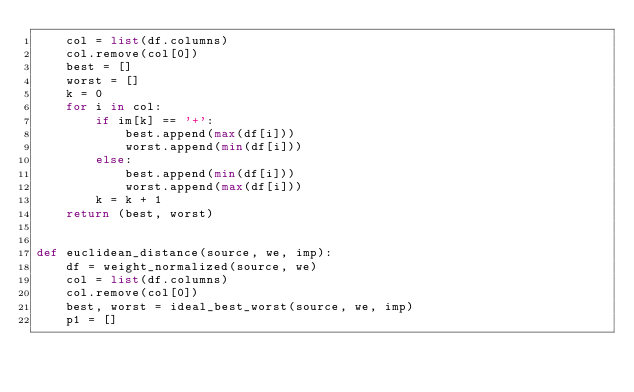Convert code to text. <code><loc_0><loc_0><loc_500><loc_500><_Python_>    col = list(df.columns)
    col.remove(col[0])
    best = []
    worst = []
    k = 0
    for i in col:
        if im[k] == '+':
            best.append(max(df[i]))
            worst.append(min(df[i]))
        else:
            best.append(min(df[i]))
            worst.append(max(df[i]))
        k = k + 1
    return (best, worst)


def euclidean_distance(source, we, imp):
    df = weight_normalized(source, we)
    col = list(df.columns)
    col.remove(col[0])
    best, worst = ideal_best_worst(source, we, imp)
    p1 = []</code> 